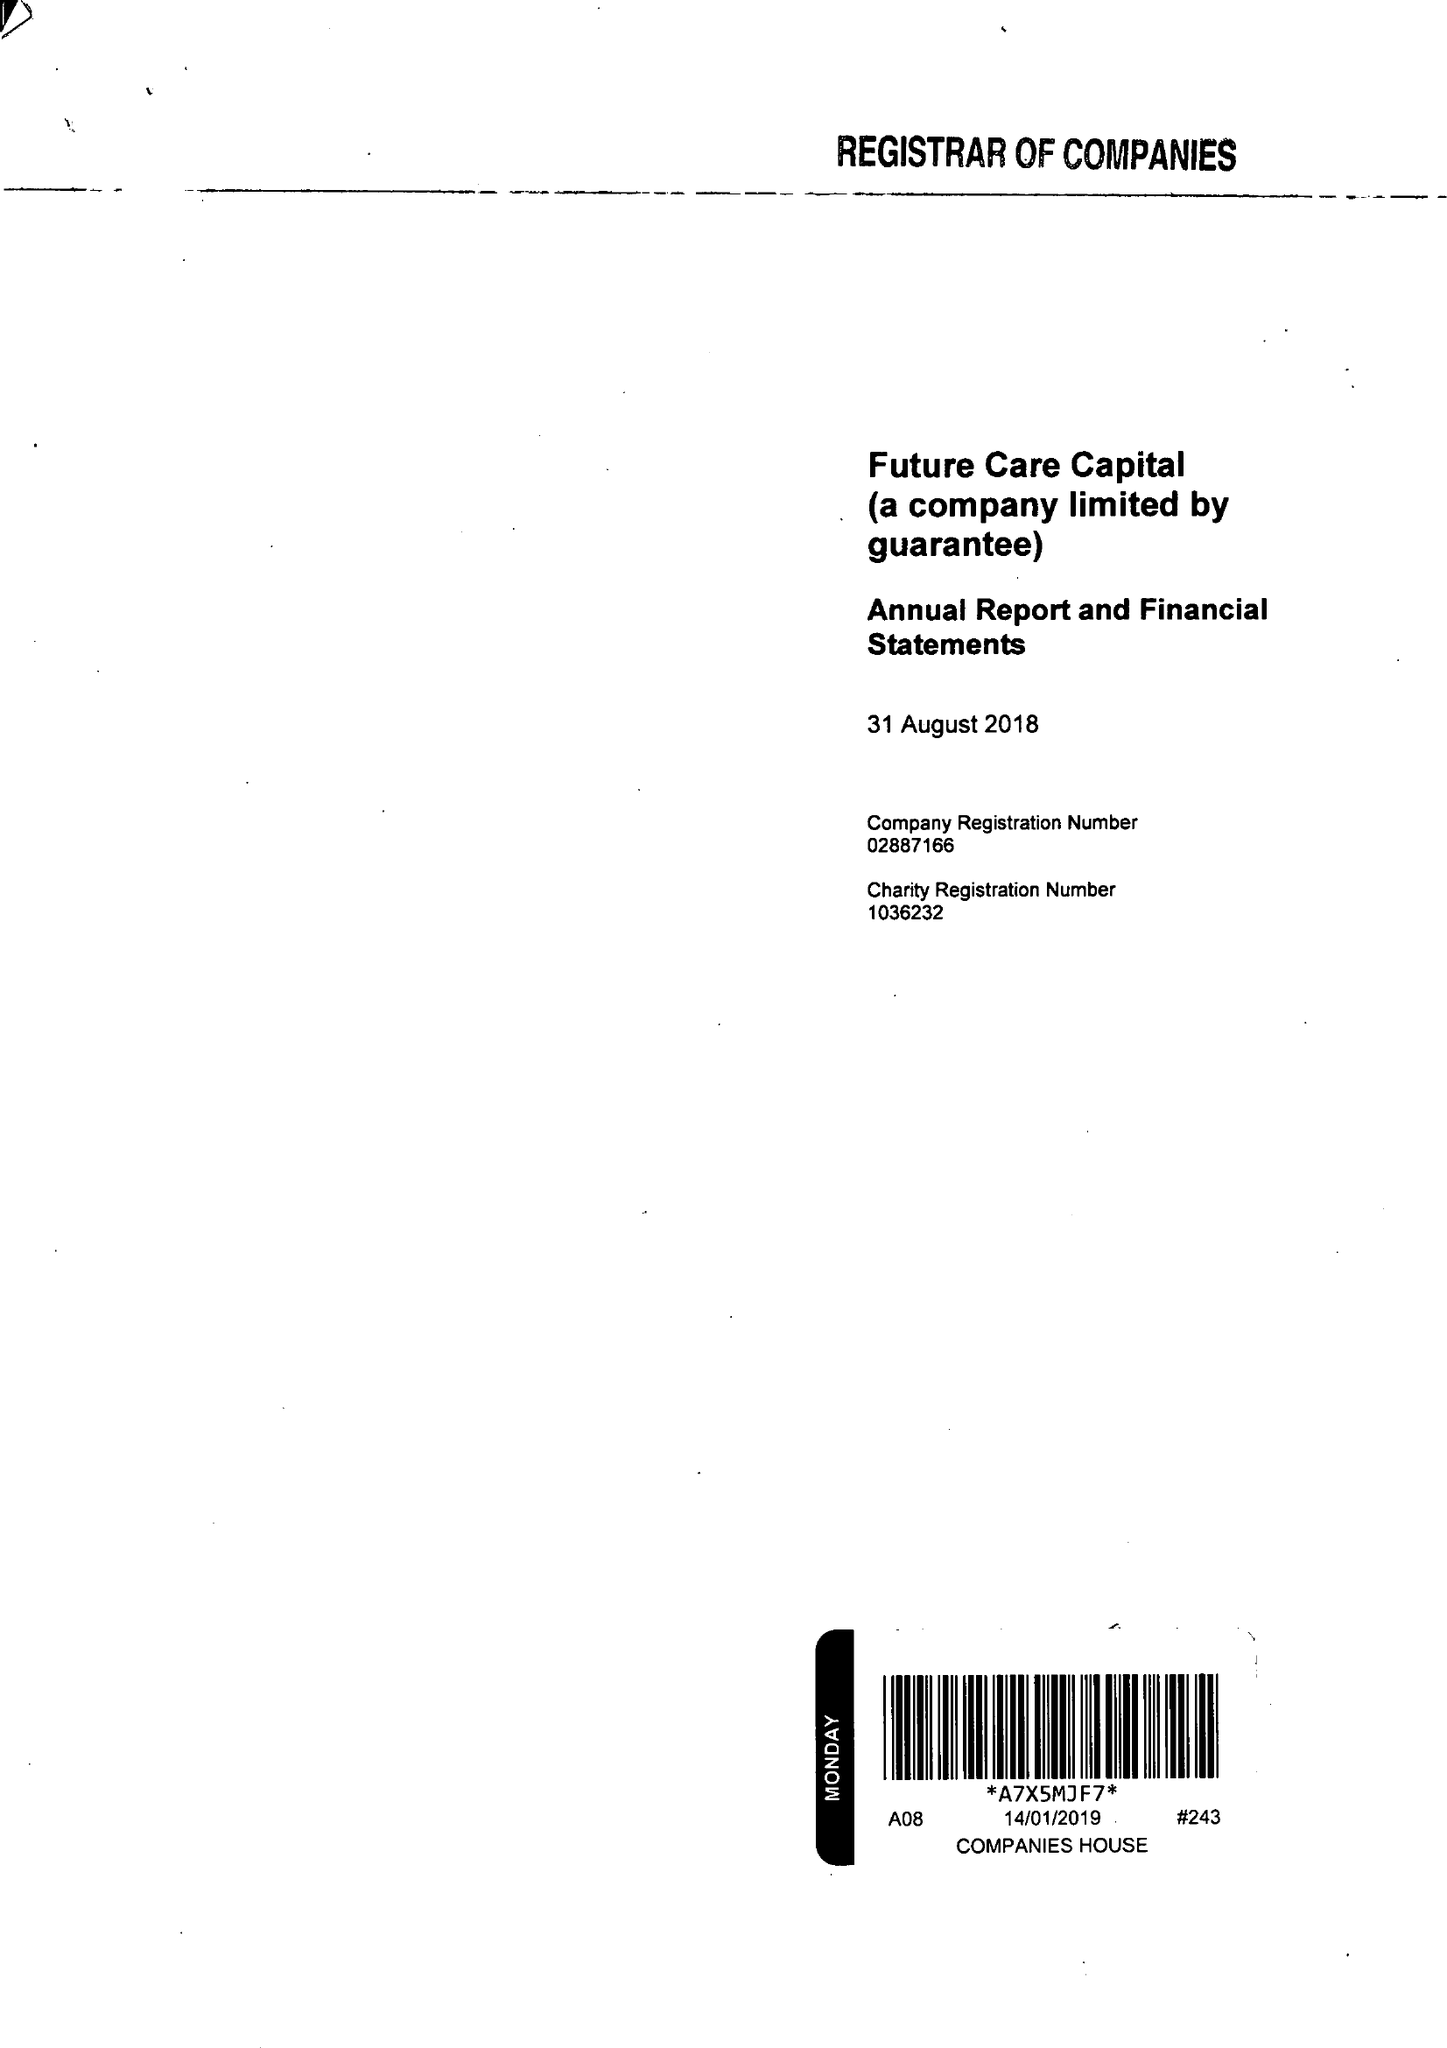What is the value for the address__post_town?
Answer the question using a single word or phrase. LONDON 